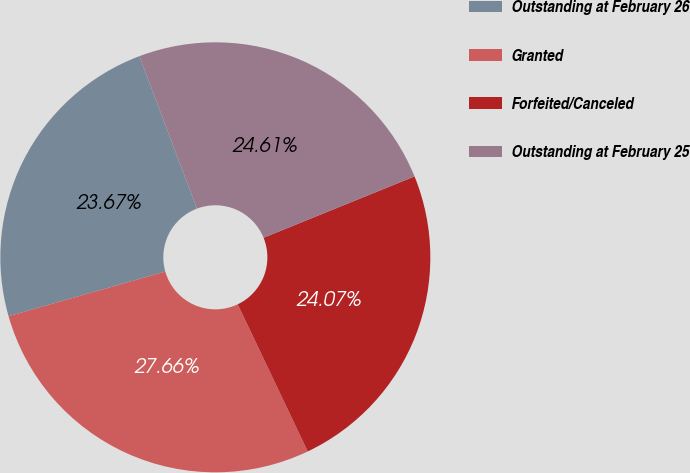Convert chart to OTSL. <chart><loc_0><loc_0><loc_500><loc_500><pie_chart><fcel>Outstanding at February 26<fcel>Granted<fcel>Forfeited/Canceled<fcel>Outstanding at February 25<nl><fcel>23.67%<fcel>27.66%<fcel>24.07%<fcel>24.61%<nl></chart> 